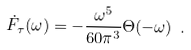Convert formula to latex. <formula><loc_0><loc_0><loc_500><loc_500>\dot { F } _ { \tau } ( \omega ) = - \frac { \omega ^ { 5 } } { 6 0 \pi ^ { 3 } } \Theta ( - \omega ) \ .</formula> 